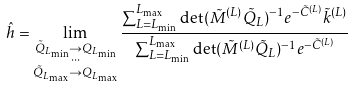Convert formula to latex. <formula><loc_0><loc_0><loc_500><loc_500>\hat { h } & = \lim _ { \substack { \tilde { Q } _ { L _ { \min } } \rightarrow { Q } _ { L _ { \min } } \\ \cdots \\ \tilde { Q } _ { L _ { \max } } \rightarrow { Q } _ { L _ { \max } } } } \frac { \sum _ { L = L _ { \min } } ^ { L _ { \max } } \det ( \tilde { M } ^ { ( L ) } \tilde { Q } _ { L } ) ^ { - 1 } e ^ { - \tilde { C } ^ { ( L ) } } \tilde { k } ^ { ( L ) } } { \sum _ { L = L _ { \min } } ^ { L _ { \max } } { \det ( \tilde { M } ^ { ( L ) } \tilde { Q } _ { L } ) ^ { - 1 } } e ^ { - \tilde { C } ^ { ( L ) } } }</formula> 